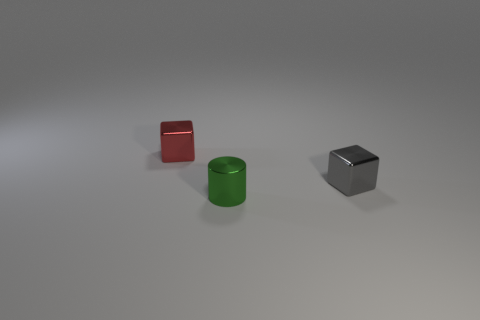What is the material of the block that is right of the shiny thing on the left side of the green thing?
Make the answer very short. Metal. What is the color of the cylinder?
Your answer should be compact. Green. Is the color of the small cube right of the red cube the same as the small object that is in front of the tiny gray metallic block?
Your answer should be compact. No. There is another shiny thing that is the same shape as the gray metal thing; what is its size?
Your answer should be very brief. Small. Is there a big cube of the same color as the shiny cylinder?
Offer a terse response. No. What number of objects are either small shiny objects left of the gray object or large red objects?
Your response must be concise. 2. There is another tiny cube that is made of the same material as the small gray cube; what color is it?
Offer a terse response. Red. Is there a cube of the same size as the metallic cylinder?
Make the answer very short. Yes. What number of things are either small cubes that are behind the small gray thing or small green cylinders that are in front of the gray shiny block?
Offer a very short reply. 2. What shape is the gray shiny object that is the same size as the green cylinder?
Provide a succinct answer. Cube. 